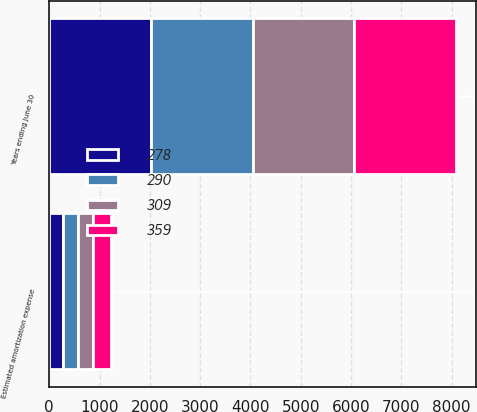Convert chart to OTSL. <chart><loc_0><loc_0><loc_500><loc_500><stacked_bar_chart><ecel><fcel>Years ending June 30<fcel>Estimated amortization expense<nl><fcel>359<fcel>2020<fcel>359<nl><fcel>309<fcel>2021<fcel>309<nl><fcel>290<fcel>2022<fcel>290<nl><fcel>278<fcel>2023<fcel>278<nl></chart> 